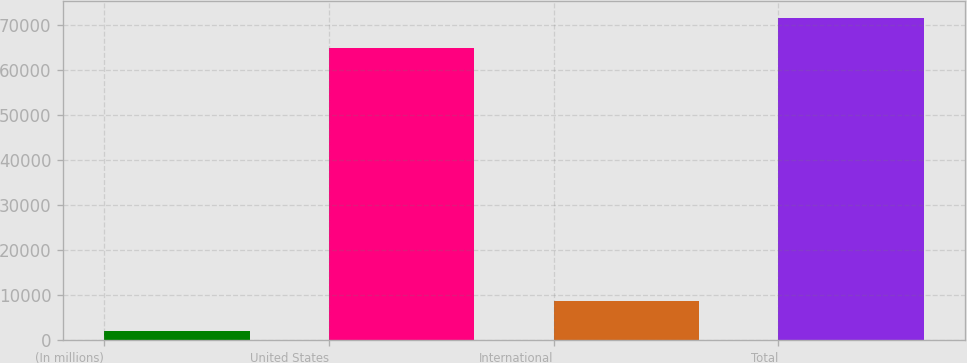Convert chart. <chart><loc_0><loc_0><loc_500><loc_500><bar_chart><fcel>(In millions)<fcel>United States<fcel>International<fcel>Total<nl><fcel>2004<fcel>64856.7<fcel>8754.21<fcel>71606.9<nl></chart> 